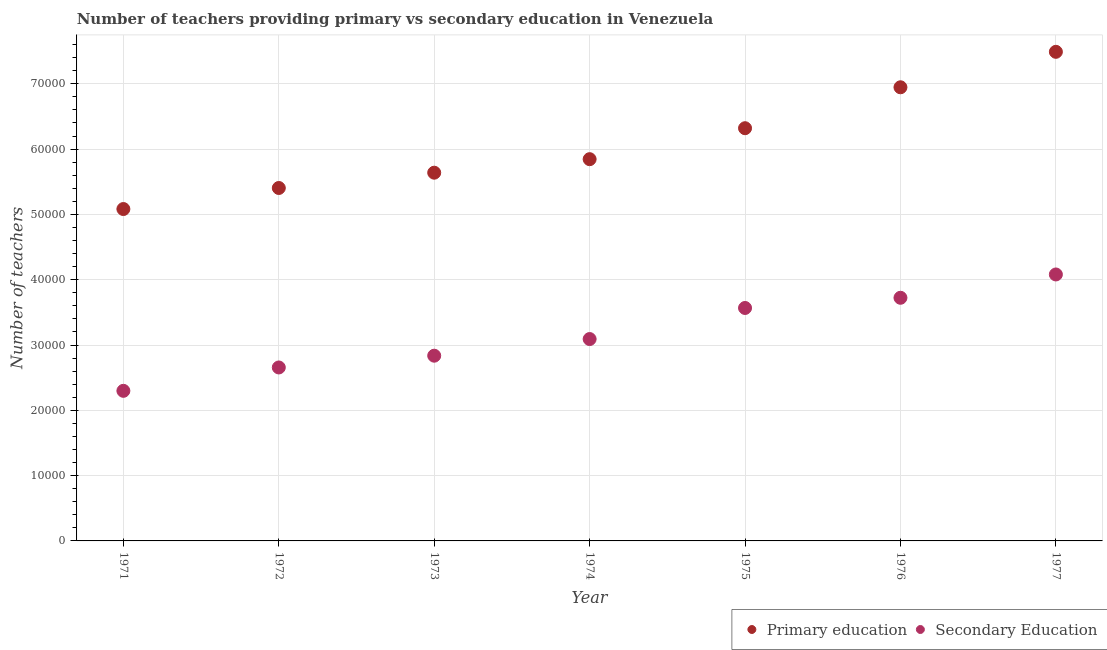Is the number of dotlines equal to the number of legend labels?
Keep it short and to the point. Yes. What is the number of primary teachers in 1971?
Offer a very short reply. 5.08e+04. Across all years, what is the maximum number of secondary teachers?
Provide a succinct answer. 4.08e+04. Across all years, what is the minimum number of secondary teachers?
Your answer should be compact. 2.30e+04. In which year was the number of secondary teachers maximum?
Make the answer very short. 1977. What is the total number of primary teachers in the graph?
Keep it short and to the point. 4.27e+05. What is the difference between the number of primary teachers in 1973 and that in 1977?
Make the answer very short. -1.85e+04. What is the difference between the number of primary teachers in 1974 and the number of secondary teachers in 1976?
Offer a terse response. 2.12e+04. What is the average number of secondary teachers per year?
Your answer should be compact. 3.18e+04. In the year 1977, what is the difference between the number of secondary teachers and number of primary teachers?
Ensure brevity in your answer.  -3.41e+04. In how many years, is the number of primary teachers greater than 12000?
Provide a succinct answer. 7. What is the ratio of the number of primary teachers in 1973 to that in 1977?
Your response must be concise. 0.75. What is the difference between the highest and the second highest number of primary teachers?
Give a very brief answer. 5429. What is the difference between the highest and the lowest number of primary teachers?
Provide a succinct answer. 2.41e+04. Is the sum of the number of secondary teachers in 1974 and 1976 greater than the maximum number of primary teachers across all years?
Offer a very short reply. No. Is the number of secondary teachers strictly greater than the number of primary teachers over the years?
Provide a short and direct response. No. How many legend labels are there?
Your response must be concise. 2. What is the title of the graph?
Make the answer very short. Number of teachers providing primary vs secondary education in Venezuela. What is the label or title of the X-axis?
Give a very brief answer. Year. What is the label or title of the Y-axis?
Your answer should be compact. Number of teachers. What is the Number of teachers in Primary education in 1971?
Your answer should be compact. 5.08e+04. What is the Number of teachers in Secondary Education in 1971?
Your answer should be compact. 2.30e+04. What is the Number of teachers of Primary education in 1972?
Your response must be concise. 5.40e+04. What is the Number of teachers of Secondary Education in 1972?
Provide a short and direct response. 2.66e+04. What is the Number of teachers in Primary education in 1973?
Your response must be concise. 5.64e+04. What is the Number of teachers in Secondary Education in 1973?
Provide a short and direct response. 2.84e+04. What is the Number of teachers of Primary education in 1974?
Give a very brief answer. 5.85e+04. What is the Number of teachers of Secondary Education in 1974?
Make the answer very short. 3.09e+04. What is the Number of teachers of Primary education in 1975?
Provide a short and direct response. 6.32e+04. What is the Number of teachers in Secondary Education in 1975?
Your response must be concise. 3.57e+04. What is the Number of teachers in Primary education in 1976?
Give a very brief answer. 6.95e+04. What is the Number of teachers of Secondary Education in 1976?
Your answer should be very brief. 3.72e+04. What is the Number of teachers of Primary education in 1977?
Your answer should be compact. 7.49e+04. What is the Number of teachers in Secondary Education in 1977?
Give a very brief answer. 4.08e+04. Across all years, what is the maximum Number of teachers of Primary education?
Offer a very short reply. 7.49e+04. Across all years, what is the maximum Number of teachers in Secondary Education?
Your answer should be very brief. 4.08e+04. Across all years, what is the minimum Number of teachers of Primary education?
Provide a succinct answer. 5.08e+04. Across all years, what is the minimum Number of teachers of Secondary Education?
Make the answer very short. 2.30e+04. What is the total Number of teachers in Primary education in the graph?
Make the answer very short. 4.27e+05. What is the total Number of teachers in Secondary Education in the graph?
Offer a very short reply. 2.23e+05. What is the difference between the Number of teachers of Primary education in 1971 and that in 1972?
Your answer should be compact. -3222. What is the difference between the Number of teachers in Secondary Education in 1971 and that in 1972?
Provide a short and direct response. -3578. What is the difference between the Number of teachers in Primary education in 1971 and that in 1973?
Your response must be concise. -5564. What is the difference between the Number of teachers of Secondary Education in 1971 and that in 1973?
Your answer should be very brief. -5380. What is the difference between the Number of teachers in Primary education in 1971 and that in 1974?
Offer a terse response. -7635. What is the difference between the Number of teachers of Secondary Education in 1971 and that in 1974?
Give a very brief answer. -7930. What is the difference between the Number of teachers in Primary education in 1971 and that in 1975?
Offer a terse response. -1.24e+04. What is the difference between the Number of teachers in Secondary Education in 1971 and that in 1975?
Provide a short and direct response. -1.27e+04. What is the difference between the Number of teachers in Primary education in 1971 and that in 1976?
Provide a succinct answer. -1.86e+04. What is the difference between the Number of teachers in Secondary Education in 1971 and that in 1976?
Provide a short and direct response. -1.42e+04. What is the difference between the Number of teachers in Primary education in 1971 and that in 1977?
Provide a short and direct response. -2.41e+04. What is the difference between the Number of teachers of Secondary Education in 1971 and that in 1977?
Provide a succinct answer. -1.78e+04. What is the difference between the Number of teachers in Primary education in 1972 and that in 1973?
Keep it short and to the point. -2342. What is the difference between the Number of teachers in Secondary Education in 1972 and that in 1973?
Provide a succinct answer. -1802. What is the difference between the Number of teachers in Primary education in 1972 and that in 1974?
Offer a terse response. -4413. What is the difference between the Number of teachers in Secondary Education in 1972 and that in 1974?
Give a very brief answer. -4352. What is the difference between the Number of teachers in Primary education in 1972 and that in 1975?
Offer a terse response. -9154. What is the difference between the Number of teachers of Secondary Education in 1972 and that in 1975?
Offer a terse response. -9110. What is the difference between the Number of teachers of Primary education in 1972 and that in 1976?
Ensure brevity in your answer.  -1.54e+04. What is the difference between the Number of teachers in Secondary Education in 1972 and that in 1976?
Make the answer very short. -1.07e+04. What is the difference between the Number of teachers of Primary education in 1972 and that in 1977?
Offer a terse response. -2.09e+04. What is the difference between the Number of teachers in Secondary Education in 1972 and that in 1977?
Your response must be concise. -1.42e+04. What is the difference between the Number of teachers of Primary education in 1973 and that in 1974?
Offer a terse response. -2071. What is the difference between the Number of teachers in Secondary Education in 1973 and that in 1974?
Offer a very short reply. -2550. What is the difference between the Number of teachers in Primary education in 1973 and that in 1975?
Provide a succinct answer. -6812. What is the difference between the Number of teachers in Secondary Education in 1973 and that in 1975?
Ensure brevity in your answer.  -7308. What is the difference between the Number of teachers in Primary education in 1973 and that in 1976?
Offer a terse response. -1.31e+04. What is the difference between the Number of teachers of Secondary Education in 1973 and that in 1976?
Provide a short and direct response. -8869. What is the difference between the Number of teachers of Primary education in 1973 and that in 1977?
Offer a very short reply. -1.85e+04. What is the difference between the Number of teachers in Secondary Education in 1973 and that in 1977?
Make the answer very short. -1.24e+04. What is the difference between the Number of teachers of Primary education in 1974 and that in 1975?
Your answer should be compact. -4741. What is the difference between the Number of teachers of Secondary Education in 1974 and that in 1975?
Your response must be concise. -4758. What is the difference between the Number of teachers of Primary education in 1974 and that in 1976?
Give a very brief answer. -1.10e+04. What is the difference between the Number of teachers of Secondary Education in 1974 and that in 1976?
Your answer should be compact. -6319. What is the difference between the Number of teachers in Primary education in 1974 and that in 1977?
Offer a very short reply. -1.64e+04. What is the difference between the Number of teachers of Secondary Education in 1974 and that in 1977?
Give a very brief answer. -9889. What is the difference between the Number of teachers in Primary education in 1975 and that in 1976?
Offer a very short reply. -6268. What is the difference between the Number of teachers of Secondary Education in 1975 and that in 1976?
Your answer should be very brief. -1561. What is the difference between the Number of teachers of Primary education in 1975 and that in 1977?
Provide a succinct answer. -1.17e+04. What is the difference between the Number of teachers in Secondary Education in 1975 and that in 1977?
Provide a short and direct response. -5131. What is the difference between the Number of teachers of Primary education in 1976 and that in 1977?
Keep it short and to the point. -5429. What is the difference between the Number of teachers in Secondary Education in 1976 and that in 1977?
Your answer should be compact. -3570. What is the difference between the Number of teachers in Primary education in 1971 and the Number of teachers in Secondary Education in 1972?
Your response must be concise. 2.43e+04. What is the difference between the Number of teachers of Primary education in 1971 and the Number of teachers of Secondary Education in 1973?
Keep it short and to the point. 2.25e+04. What is the difference between the Number of teachers of Primary education in 1971 and the Number of teachers of Secondary Education in 1974?
Provide a short and direct response. 1.99e+04. What is the difference between the Number of teachers of Primary education in 1971 and the Number of teachers of Secondary Education in 1975?
Offer a very short reply. 1.52e+04. What is the difference between the Number of teachers of Primary education in 1971 and the Number of teachers of Secondary Education in 1976?
Offer a terse response. 1.36e+04. What is the difference between the Number of teachers in Primary education in 1971 and the Number of teachers in Secondary Education in 1977?
Provide a succinct answer. 1.00e+04. What is the difference between the Number of teachers of Primary education in 1972 and the Number of teachers of Secondary Education in 1973?
Your answer should be compact. 2.57e+04. What is the difference between the Number of teachers in Primary education in 1972 and the Number of teachers in Secondary Education in 1974?
Your response must be concise. 2.31e+04. What is the difference between the Number of teachers in Primary education in 1972 and the Number of teachers in Secondary Education in 1975?
Keep it short and to the point. 1.84e+04. What is the difference between the Number of teachers in Primary education in 1972 and the Number of teachers in Secondary Education in 1976?
Keep it short and to the point. 1.68e+04. What is the difference between the Number of teachers in Primary education in 1972 and the Number of teachers in Secondary Education in 1977?
Provide a succinct answer. 1.32e+04. What is the difference between the Number of teachers of Primary education in 1973 and the Number of teachers of Secondary Education in 1974?
Provide a short and direct response. 2.55e+04. What is the difference between the Number of teachers of Primary education in 1973 and the Number of teachers of Secondary Education in 1975?
Provide a succinct answer. 2.07e+04. What is the difference between the Number of teachers of Primary education in 1973 and the Number of teachers of Secondary Education in 1976?
Your answer should be very brief. 1.92e+04. What is the difference between the Number of teachers in Primary education in 1973 and the Number of teachers in Secondary Education in 1977?
Offer a very short reply. 1.56e+04. What is the difference between the Number of teachers of Primary education in 1974 and the Number of teachers of Secondary Education in 1975?
Your answer should be compact. 2.28e+04. What is the difference between the Number of teachers in Primary education in 1974 and the Number of teachers in Secondary Education in 1976?
Keep it short and to the point. 2.12e+04. What is the difference between the Number of teachers of Primary education in 1974 and the Number of teachers of Secondary Education in 1977?
Offer a terse response. 1.77e+04. What is the difference between the Number of teachers of Primary education in 1975 and the Number of teachers of Secondary Education in 1976?
Your answer should be compact. 2.60e+04. What is the difference between the Number of teachers in Primary education in 1975 and the Number of teachers in Secondary Education in 1977?
Offer a very short reply. 2.24e+04. What is the difference between the Number of teachers in Primary education in 1976 and the Number of teachers in Secondary Education in 1977?
Make the answer very short. 2.87e+04. What is the average Number of teachers of Primary education per year?
Give a very brief answer. 6.10e+04. What is the average Number of teachers in Secondary Education per year?
Your response must be concise. 3.18e+04. In the year 1971, what is the difference between the Number of teachers in Primary education and Number of teachers in Secondary Education?
Your response must be concise. 2.78e+04. In the year 1972, what is the difference between the Number of teachers of Primary education and Number of teachers of Secondary Education?
Provide a succinct answer. 2.75e+04. In the year 1973, what is the difference between the Number of teachers of Primary education and Number of teachers of Secondary Education?
Provide a short and direct response. 2.80e+04. In the year 1974, what is the difference between the Number of teachers of Primary education and Number of teachers of Secondary Education?
Give a very brief answer. 2.75e+04. In the year 1975, what is the difference between the Number of teachers of Primary education and Number of teachers of Secondary Education?
Make the answer very short. 2.75e+04. In the year 1976, what is the difference between the Number of teachers in Primary education and Number of teachers in Secondary Education?
Give a very brief answer. 3.22e+04. In the year 1977, what is the difference between the Number of teachers in Primary education and Number of teachers in Secondary Education?
Give a very brief answer. 3.41e+04. What is the ratio of the Number of teachers in Primary education in 1971 to that in 1972?
Your answer should be very brief. 0.94. What is the ratio of the Number of teachers of Secondary Education in 1971 to that in 1972?
Ensure brevity in your answer.  0.87. What is the ratio of the Number of teachers of Primary education in 1971 to that in 1973?
Provide a short and direct response. 0.9. What is the ratio of the Number of teachers in Secondary Education in 1971 to that in 1973?
Provide a short and direct response. 0.81. What is the ratio of the Number of teachers of Primary education in 1971 to that in 1974?
Make the answer very short. 0.87. What is the ratio of the Number of teachers in Secondary Education in 1971 to that in 1974?
Your response must be concise. 0.74. What is the ratio of the Number of teachers of Primary education in 1971 to that in 1975?
Provide a short and direct response. 0.8. What is the ratio of the Number of teachers of Secondary Education in 1971 to that in 1975?
Offer a very short reply. 0.64. What is the ratio of the Number of teachers in Primary education in 1971 to that in 1976?
Give a very brief answer. 0.73. What is the ratio of the Number of teachers in Secondary Education in 1971 to that in 1976?
Your answer should be compact. 0.62. What is the ratio of the Number of teachers in Primary education in 1971 to that in 1977?
Your answer should be very brief. 0.68. What is the ratio of the Number of teachers in Secondary Education in 1971 to that in 1977?
Your answer should be very brief. 0.56. What is the ratio of the Number of teachers in Primary education in 1972 to that in 1973?
Offer a terse response. 0.96. What is the ratio of the Number of teachers of Secondary Education in 1972 to that in 1973?
Make the answer very short. 0.94. What is the ratio of the Number of teachers of Primary education in 1972 to that in 1974?
Give a very brief answer. 0.92. What is the ratio of the Number of teachers of Secondary Education in 1972 to that in 1974?
Ensure brevity in your answer.  0.86. What is the ratio of the Number of teachers in Primary education in 1972 to that in 1975?
Make the answer very short. 0.86. What is the ratio of the Number of teachers of Secondary Education in 1972 to that in 1975?
Offer a terse response. 0.74. What is the ratio of the Number of teachers in Primary education in 1972 to that in 1976?
Your answer should be very brief. 0.78. What is the ratio of the Number of teachers of Secondary Education in 1972 to that in 1976?
Keep it short and to the point. 0.71. What is the ratio of the Number of teachers of Primary education in 1972 to that in 1977?
Give a very brief answer. 0.72. What is the ratio of the Number of teachers of Secondary Education in 1972 to that in 1977?
Offer a terse response. 0.65. What is the ratio of the Number of teachers in Primary education in 1973 to that in 1974?
Your response must be concise. 0.96. What is the ratio of the Number of teachers in Secondary Education in 1973 to that in 1974?
Your answer should be compact. 0.92. What is the ratio of the Number of teachers of Primary education in 1973 to that in 1975?
Give a very brief answer. 0.89. What is the ratio of the Number of teachers in Secondary Education in 1973 to that in 1975?
Your response must be concise. 0.8. What is the ratio of the Number of teachers in Primary education in 1973 to that in 1976?
Give a very brief answer. 0.81. What is the ratio of the Number of teachers of Secondary Education in 1973 to that in 1976?
Your answer should be compact. 0.76. What is the ratio of the Number of teachers in Primary education in 1973 to that in 1977?
Your response must be concise. 0.75. What is the ratio of the Number of teachers in Secondary Education in 1973 to that in 1977?
Ensure brevity in your answer.  0.7. What is the ratio of the Number of teachers in Primary education in 1974 to that in 1975?
Offer a very short reply. 0.93. What is the ratio of the Number of teachers of Secondary Education in 1974 to that in 1975?
Your answer should be compact. 0.87. What is the ratio of the Number of teachers in Primary education in 1974 to that in 1976?
Offer a terse response. 0.84. What is the ratio of the Number of teachers in Secondary Education in 1974 to that in 1976?
Your answer should be very brief. 0.83. What is the ratio of the Number of teachers in Primary education in 1974 to that in 1977?
Offer a terse response. 0.78. What is the ratio of the Number of teachers in Secondary Education in 1974 to that in 1977?
Provide a short and direct response. 0.76. What is the ratio of the Number of teachers in Primary education in 1975 to that in 1976?
Your answer should be very brief. 0.91. What is the ratio of the Number of teachers in Secondary Education in 1975 to that in 1976?
Your answer should be very brief. 0.96. What is the ratio of the Number of teachers in Primary education in 1975 to that in 1977?
Give a very brief answer. 0.84. What is the ratio of the Number of teachers in Secondary Education in 1975 to that in 1977?
Your response must be concise. 0.87. What is the ratio of the Number of teachers in Primary education in 1976 to that in 1977?
Your answer should be very brief. 0.93. What is the ratio of the Number of teachers in Secondary Education in 1976 to that in 1977?
Your answer should be very brief. 0.91. What is the difference between the highest and the second highest Number of teachers in Primary education?
Keep it short and to the point. 5429. What is the difference between the highest and the second highest Number of teachers of Secondary Education?
Provide a succinct answer. 3570. What is the difference between the highest and the lowest Number of teachers in Primary education?
Make the answer very short. 2.41e+04. What is the difference between the highest and the lowest Number of teachers in Secondary Education?
Your answer should be compact. 1.78e+04. 